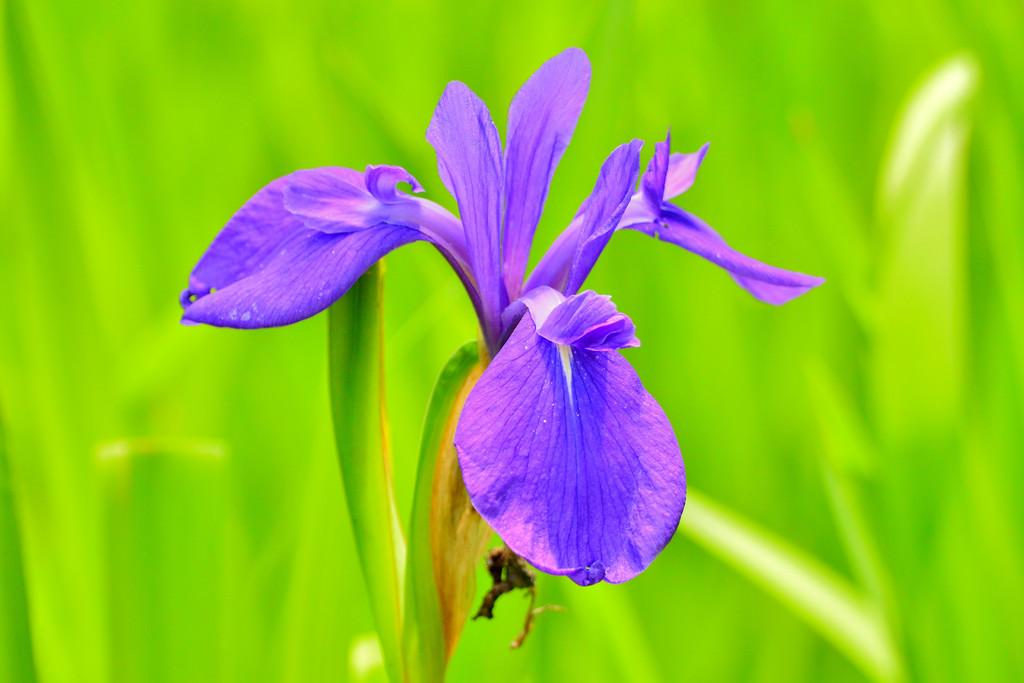What is the main subject of the image? There is a flower in the center of the image. Can you describe the flower in the image? Unfortunately, the facts provided do not give any details about the flower's appearance or type. Is there anything else in the image besides the flower? The facts provided do not mention any other objects or subjects in the image. What date is marked on the calendar in the image? There is no calendar present in the image, as the facts provided only mention a flower. How many people are using the lift in the image? There is no lift present in the image, as the facts provided only mention a flower. 